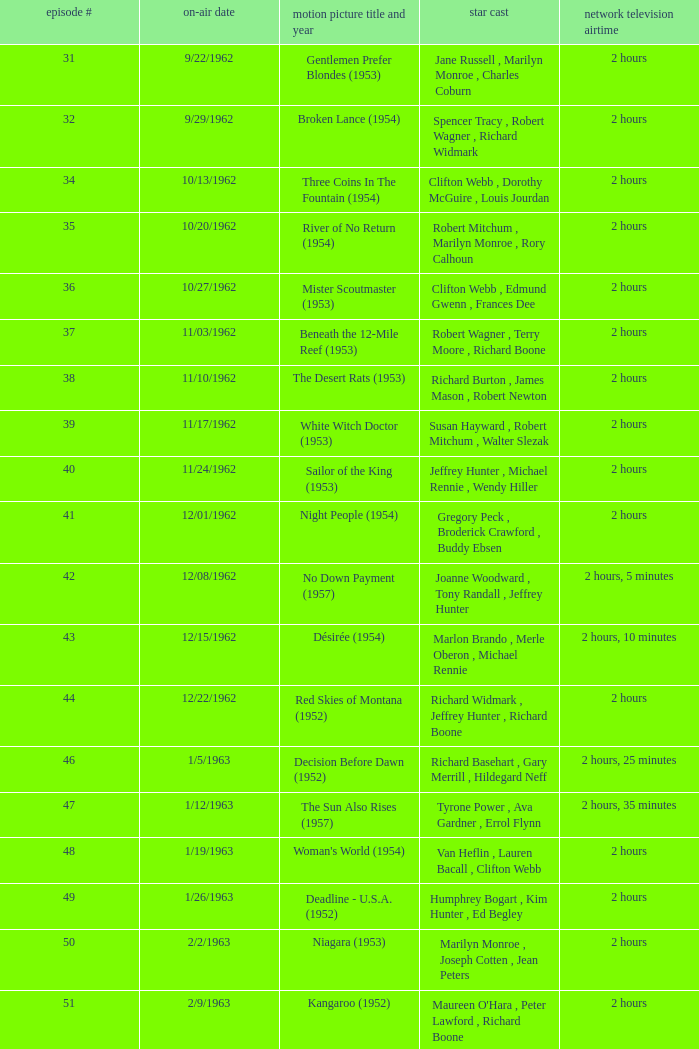How many runtimes does episode 53 have? 1.0. 